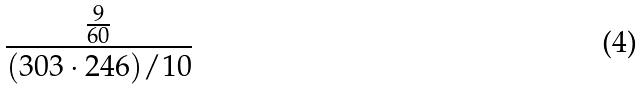<formula> <loc_0><loc_0><loc_500><loc_500>\frac { \frac { 9 } { 6 0 } } { ( 3 0 3 \cdot 2 4 6 ) / 1 0 }</formula> 